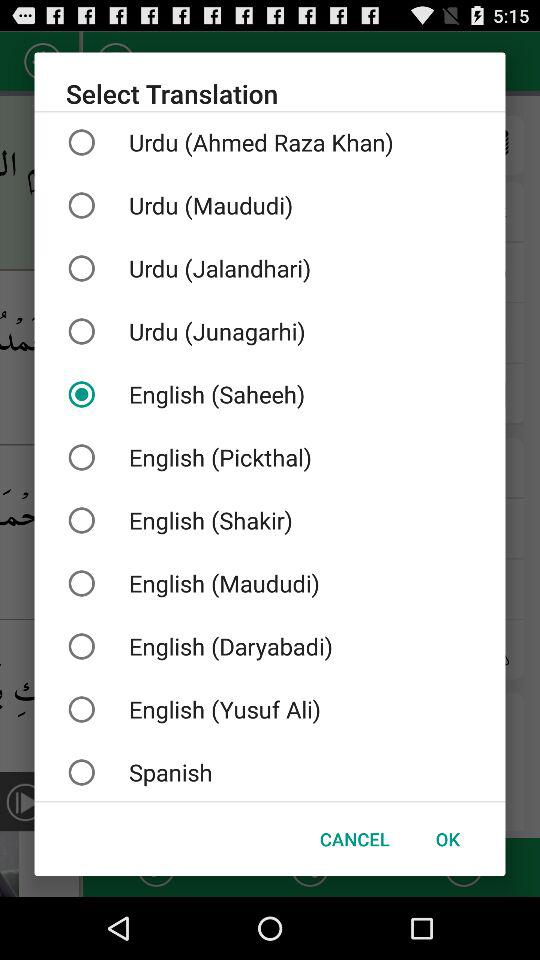Which translation language is selected? The selected language is "English (Saheeh)". 